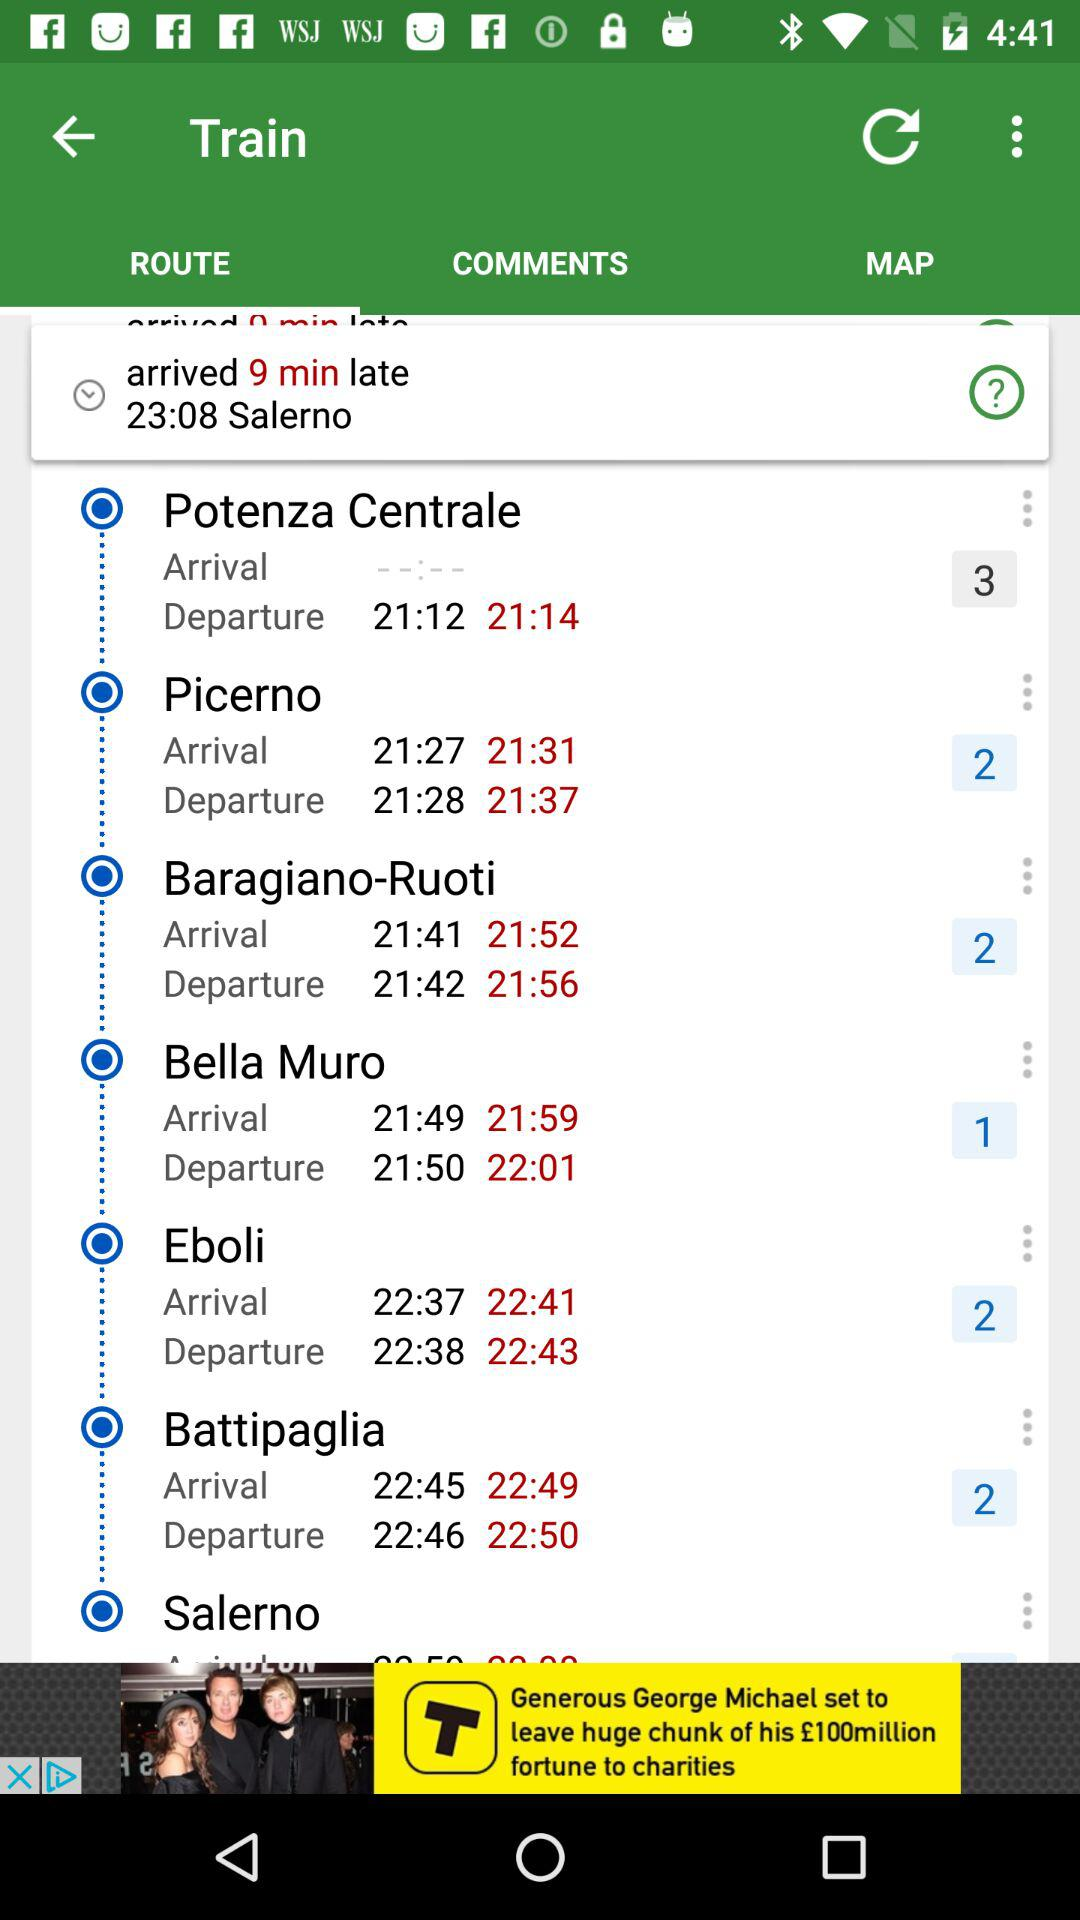What is the actual departure time of the train at "Picerno"? The actual departure time of the train at "Picerno" is 21:37. 